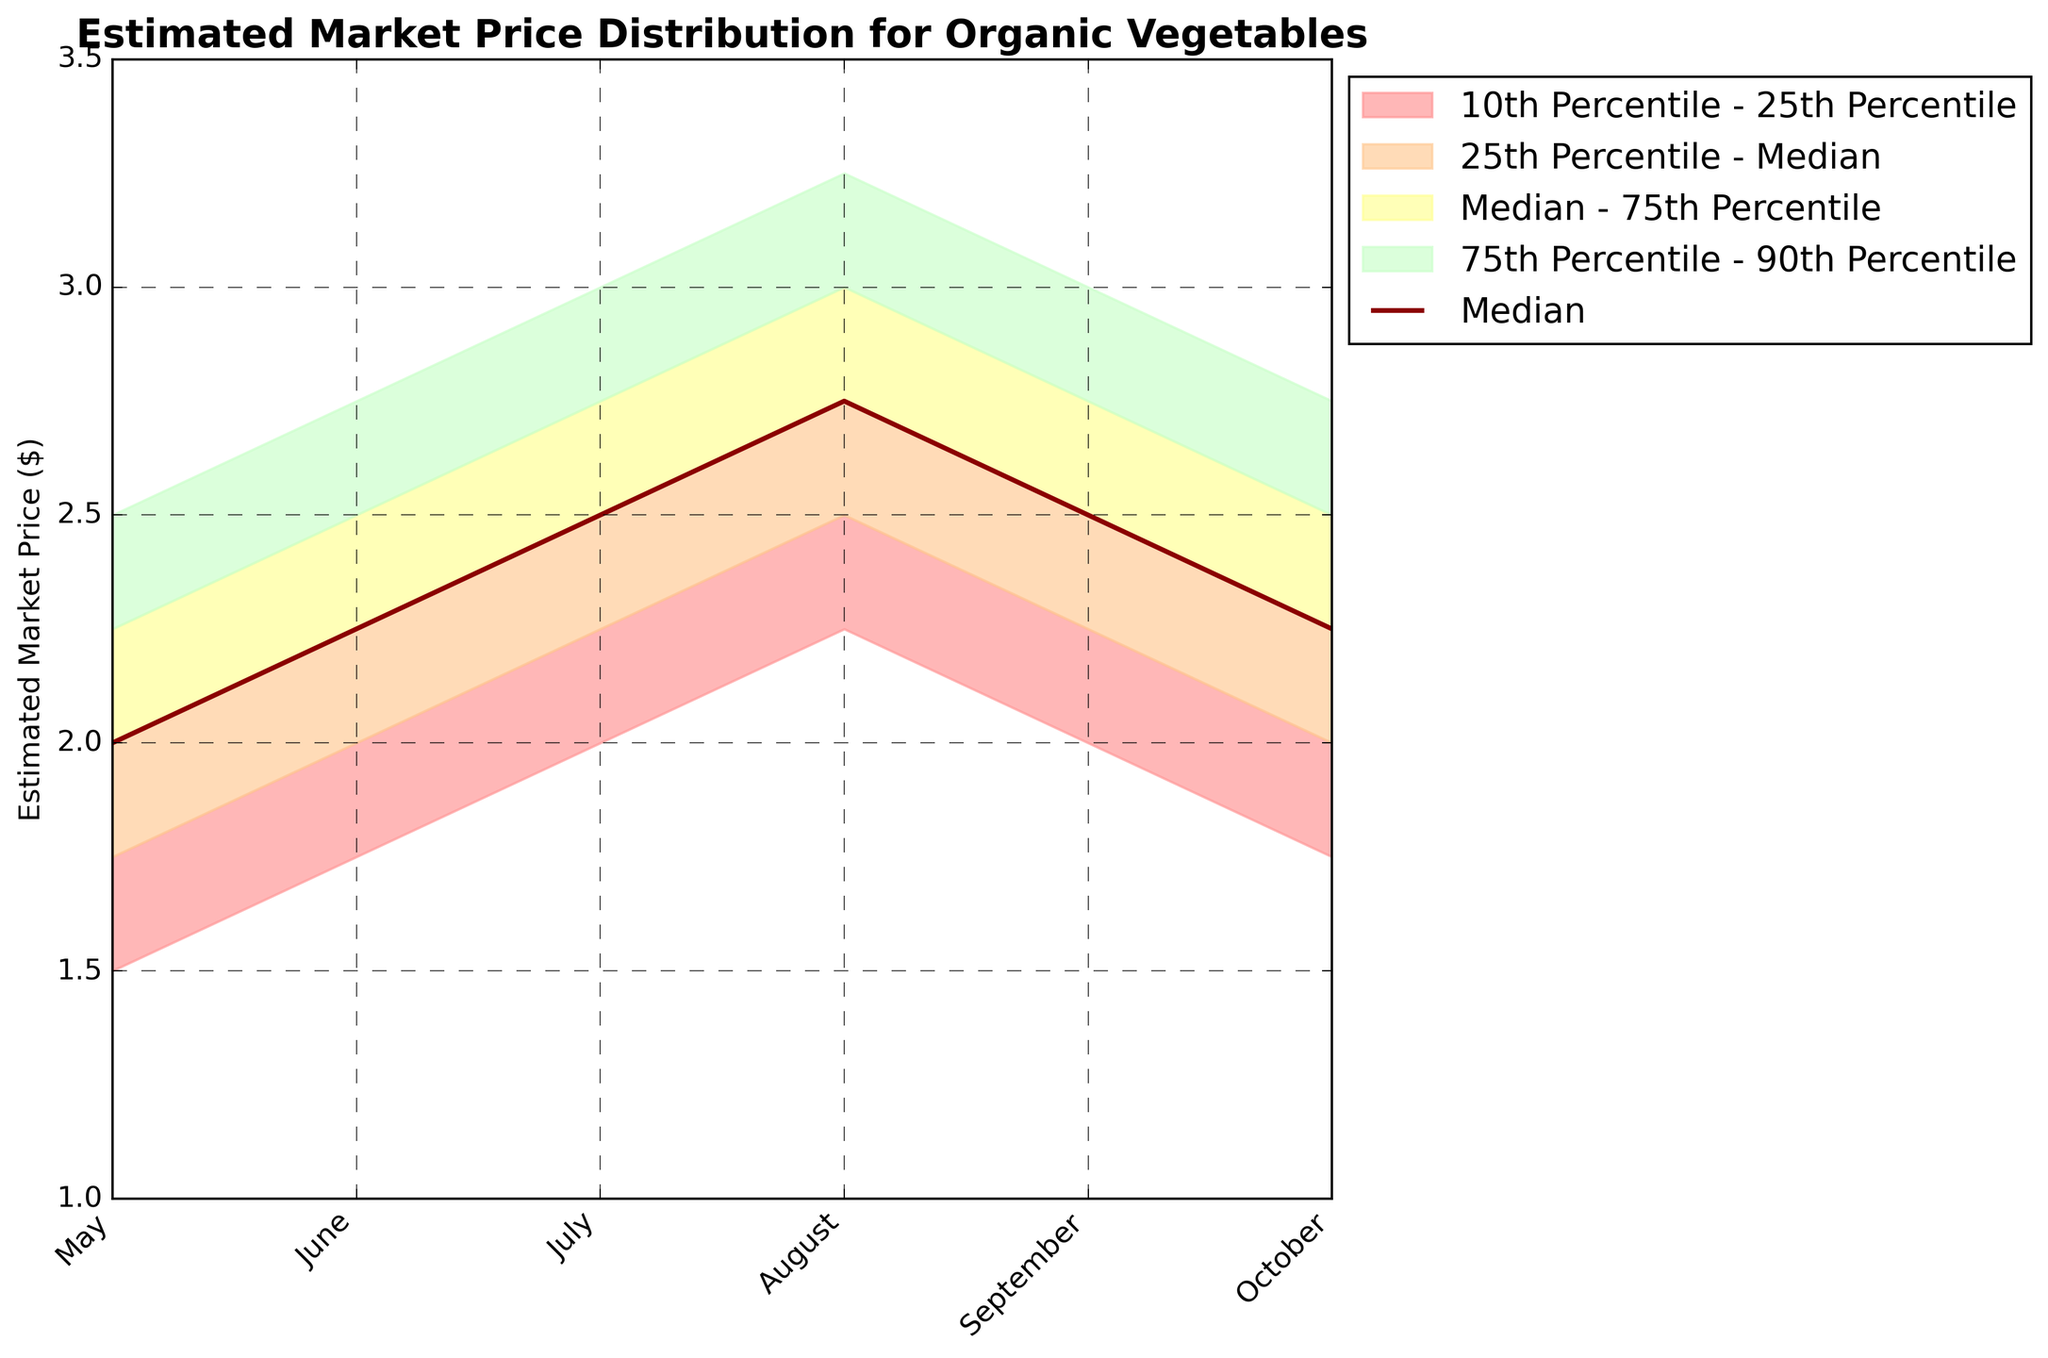What is the title of the chart? The title of the chart is typically placed at the top of the figure and is meant to provide a concise description of what the chart represents. In this case, it reads "Estimated Market Price Distribution for Organic Vegetables".
Answer: Estimated Market Price Distribution for Organic Vegetables Which months have the highest median estimated market price for organic vegetables? To find the highest median price, identify the values from the median (dark red line) for each month. August has the highest median value of $2.75.
Answer: August What is the range of the 10th Percentile in June? Identify the 10th Percentile line which ranges from $1.75 in June to $1.75.
Answer: $1.75 By how much does the median market price change from May to August? Extract the median prices for May ($2.00) and August ($2.75) and calculate the difference: $2.75 - $2.00 = $0.75.
Answer: $0.75 In which month is the estimated market price more variable? The variability can be observed by looking at the spread between the 10th and 90th Percentiles. August shows the highest variability ranging from $2.25 to $3.25, which is a spread of $1.00.
Answer: August How does the 75th Percentile compare between July and September? Compare the 75th Percentile in July ($2.75) and September ($2.75) to see if they are equal. Both have the same value.
Answer: Equal What is the estimated market price range for October? Identify the price range for October from the 10th to the 90th Percentile: $1.75 to $2.75, hence the range is $2.75 - $1.75 = $1.00.
Answer: $1.00 In which month does the median market price decrease compared to the previous month? Analyze the median prices and observe if there are any monthly decreases, for instance between August ($2.75) and September ($2.50), there is a decrease of $0.25.
Answer: September 